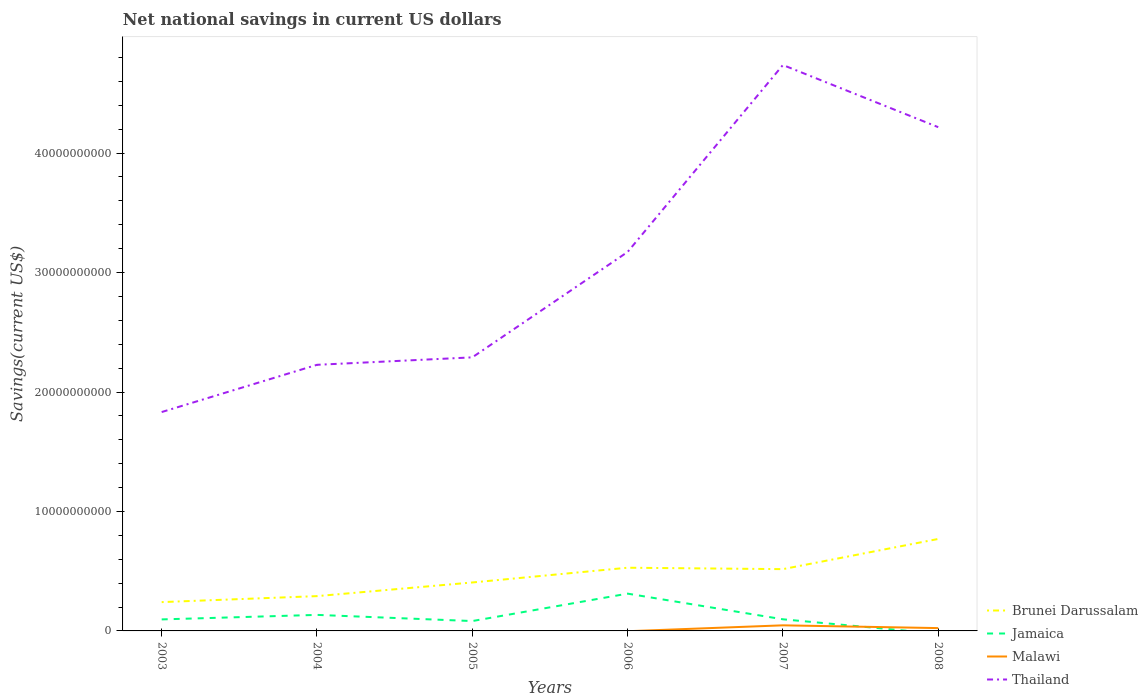Does the line corresponding to Jamaica intersect with the line corresponding to Thailand?
Your answer should be compact. No. Is the number of lines equal to the number of legend labels?
Give a very brief answer. No. What is the total net national savings in Brunei Darussalam in the graph?
Provide a succinct answer. -1.64e+09. What is the difference between the highest and the second highest net national savings in Malawi?
Your answer should be very brief. 4.68e+08. How many lines are there?
Provide a short and direct response. 4. How many years are there in the graph?
Make the answer very short. 6. Does the graph contain grids?
Your response must be concise. No. How are the legend labels stacked?
Offer a very short reply. Vertical. What is the title of the graph?
Offer a very short reply. Net national savings in current US dollars. Does "Micronesia" appear as one of the legend labels in the graph?
Provide a succinct answer. No. What is the label or title of the Y-axis?
Make the answer very short. Savings(current US$). What is the Savings(current US$) of Brunei Darussalam in 2003?
Make the answer very short. 2.41e+09. What is the Savings(current US$) of Jamaica in 2003?
Your answer should be very brief. 9.64e+08. What is the Savings(current US$) in Malawi in 2003?
Your response must be concise. 0. What is the Savings(current US$) in Thailand in 2003?
Your answer should be very brief. 1.83e+1. What is the Savings(current US$) of Brunei Darussalam in 2004?
Your response must be concise. 2.91e+09. What is the Savings(current US$) of Jamaica in 2004?
Provide a succinct answer. 1.34e+09. What is the Savings(current US$) of Malawi in 2004?
Offer a terse response. 0. What is the Savings(current US$) of Thailand in 2004?
Your answer should be very brief. 2.23e+1. What is the Savings(current US$) of Brunei Darussalam in 2005?
Offer a terse response. 4.06e+09. What is the Savings(current US$) of Jamaica in 2005?
Your answer should be compact. 8.26e+08. What is the Savings(current US$) in Thailand in 2005?
Make the answer very short. 2.29e+1. What is the Savings(current US$) in Brunei Darussalam in 2006?
Offer a very short reply. 5.29e+09. What is the Savings(current US$) in Jamaica in 2006?
Keep it short and to the point. 3.12e+09. What is the Savings(current US$) of Thailand in 2006?
Ensure brevity in your answer.  3.17e+1. What is the Savings(current US$) of Brunei Darussalam in 2007?
Provide a succinct answer. 5.17e+09. What is the Savings(current US$) in Jamaica in 2007?
Your answer should be compact. 9.73e+08. What is the Savings(current US$) of Malawi in 2007?
Your answer should be compact. 4.68e+08. What is the Savings(current US$) of Thailand in 2007?
Your response must be concise. 4.74e+1. What is the Savings(current US$) of Brunei Darussalam in 2008?
Your response must be concise. 7.70e+09. What is the Savings(current US$) in Malawi in 2008?
Give a very brief answer. 2.37e+08. What is the Savings(current US$) in Thailand in 2008?
Your response must be concise. 4.22e+1. Across all years, what is the maximum Savings(current US$) of Brunei Darussalam?
Offer a terse response. 7.70e+09. Across all years, what is the maximum Savings(current US$) of Jamaica?
Your answer should be compact. 3.12e+09. Across all years, what is the maximum Savings(current US$) of Malawi?
Offer a terse response. 4.68e+08. Across all years, what is the maximum Savings(current US$) in Thailand?
Make the answer very short. 4.74e+1. Across all years, what is the minimum Savings(current US$) of Brunei Darussalam?
Give a very brief answer. 2.41e+09. Across all years, what is the minimum Savings(current US$) of Jamaica?
Give a very brief answer. 0. Across all years, what is the minimum Savings(current US$) in Malawi?
Provide a short and direct response. 0. Across all years, what is the minimum Savings(current US$) of Thailand?
Your response must be concise. 1.83e+1. What is the total Savings(current US$) of Brunei Darussalam in the graph?
Offer a very short reply. 2.75e+1. What is the total Savings(current US$) in Jamaica in the graph?
Offer a terse response. 7.23e+09. What is the total Savings(current US$) of Malawi in the graph?
Keep it short and to the point. 7.05e+08. What is the total Savings(current US$) in Thailand in the graph?
Your response must be concise. 1.85e+11. What is the difference between the Savings(current US$) in Brunei Darussalam in 2003 and that in 2004?
Provide a succinct answer. -5.01e+08. What is the difference between the Savings(current US$) in Jamaica in 2003 and that in 2004?
Give a very brief answer. -3.78e+08. What is the difference between the Savings(current US$) of Thailand in 2003 and that in 2004?
Ensure brevity in your answer.  -3.95e+09. What is the difference between the Savings(current US$) of Brunei Darussalam in 2003 and that in 2005?
Provide a short and direct response. -1.64e+09. What is the difference between the Savings(current US$) of Jamaica in 2003 and that in 2005?
Provide a succinct answer. 1.38e+08. What is the difference between the Savings(current US$) of Thailand in 2003 and that in 2005?
Offer a very short reply. -4.58e+09. What is the difference between the Savings(current US$) in Brunei Darussalam in 2003 and that in 2006?
Provide a short and direct response. -2.88e+09. What is the difference between the Savings(current US$) in Jamaica in 2003 and that in 2006?
Your response must be concise. -2.16e+09. What is the difference between the Savings(current US$) in Thailand in 2003 and that in 2006?
Give a very brief answer. -1.34e+1. What is the difference between the Savings(current US$) of Brunei Darussalam in 2003 and that in 2007?
Offer a terse response. -2.76e+09. What is the difference between the Savings(current US$) of Jamaica in 2003 and that in 2007?
Provide a short and direct response. -9.20e+06. What is the difference between the Savings(current US$) in Thailand in 2003 and that in 2007?
Provide a short and direct response. -2.91e+1. What is the difference between the Savings(current US$) in Brunei Darussalam in 2003 and that in 2008?
Your answer should be very brief. -5.29e+09. What is the difference between the Savings(current US$) of Thailand in 2003 and that in 2008?
Offer a terse response. -2.38e+1. What is the difference between the Savings(current US$) in Brunei Darussalam in 2004 and that in 2005?
Offer a terse response. -1.14e+09. What is the difference between the Savings(current US$) of Jamaica in 2004 and that in 2005?
Give a very brief answer. 5.16e+08. What is the difference between the Savings(current US$) in Thailand in 2004 and that in 2005?
Offer a very short reply. -6.24e+08. What is the difference between the Savings(current US$) of Brunei Darussalam in 2004 and that in 2006?
Provide a short and direct response. -2.38e+09. What is the difference between the Savings(current US$) in Jamaica in 2004 and that in 2006?
Give a very brief answer. -1.78e+09. What is the difference between the Savings(current US$) of Thailand in 2004 and that in 2006?
Your response must be concise. -9.45e+09. What is the difference between the Savings(current US$) of Brunei Darussalam in 2004 and that in 2007?
Ensure brevity in your answer.  -2.26e+09. What is the difference between the Savings(current US$) in Jamaica in 2004 and that in 2007?
Make the answer very short. 3.69e+08. What is the difference between the Savings(current US$) in Thailand in 2004 and that in 2007?
Your response must be concise. -2.51e+1. What is the difference between the Savings(current US$) of Brunei Darussalam in 2004 and that in 2008?
Make the answer very short. -4.79e+09. What is the difference between the Savings(current US$) in Thailand in 2004 and that in 2008?
Give a very brief answer. -1.99e+1. What is the difference between the Savings(current US$) of Brunei Darussalam in 2005 and that in 2006?
Offer a terse response. -1.23e+09. What is the difference between the Savings(current US$) in Jamaica in 2005 and that in 2006?
Make the answer very short. -2.30e+09. What is the difference between the Savings(current US$) of Thailand in 2005 and that in 2006?
Your answer should be compact. -8.82e+09. What is the difference between the Savings(current US$) of Brunei Darussalam in 2005 and that in 2007?
Make the answer very short. -1.12e+09. What is the difference between the Savings(current US$) in Jamaica in 2005 and that in 2007?
Provide a short and direct response. -1.47e+08. What is the difference between the Savings(current US$) of Thailand in 2005 and that in 2007?
Keep it short and to the point. -2.45e+1. What is the difference between the Savings(current US$) in Brunei Darussalam in 2005 and that in 2008?
Provide a succinct answer. -3.64e+09. What is the difference between the Savings(current US$) of Thailand in 2005 and that in 2008?
Make the answer very short. -1.93e+1. What is the difference between the Savings(current US$) in Brunei Darussalam in 2006 and that in 2007?
Offer a very short reply. 1.18e+08. What is the difference between the Savings(current US$) of Jamaica in 2006 and that in 2007?
Keep it short and to the point. 2.15e+09. What is the difference between the Savings(current US$) of Thailand in 2006 and that in 2007?
Offer a very short reply. -1.57e+1. What is the difference between the Savings(current US$) of Brunei Darussalam in 2006 and that in 2008?
Your response must be concise. -2.41e+09. What is the difference between the Savings(current US$) in Thailand in 2006 and that in 2008?
Your response must be concise. -1.04e+1. What is the difference between the Savings(current US$) of Brunei Darussalam in 2007 and that in 2008?
Keep it short and to the point. -2.53e+09. What is the difference between the Savings(current US$) of Malawi in 2007 and that in 2008?
Offer a terse response. 2.31e+08. What is the difference between the Savings(current US$) in Thailand in 2007 and that in 2008?
Your answer should be very brief. 5.20e+09. What is the difference between the Savings(current US$) of Brunei Darussalam in 2003 and the Savings(current US$) of Jamaica in 2004?
Your answer should be very brief. 1.07e+09. What is the difference between the Savings(current US$) of Brunei Darussalam in 2003 and the Savings(current US$) of Thailand in 2004?
Keep it short and to the point. -1.99e+1. What is the difference between the Savings(current US$) of Jamaica in 2003 and the Savings(current US$) of Thailand in 2004?
Give a very brief answer. -2.13e+1. What is the difference between the Savings(current US$) in Brunei Darussalam in 2003 and the Savings(current US$) in Jamaica in 2005?
Provide a short and direct response. 1.59e+09. What is the difference between the Savings(current US$) in Brunei Darussalam in 2003 and the Savings(current US$) in Thailand in 2005?
Your answer should be very brief. -2.05e+1. What is the difference between the Savings(current US$) in Jamaica in 2003 and the Savings(current US$) in Thailand in 2005?
Your answer should be compact. -2.19e+1. What is the difference between the Savings(current US$) of Brunei Darussalam in 2003 and the Savings(current US$) of Jamaica in 2006?
Give a very brief answer. -7.09e+08. What is the difference between the Savings(current US$) of Brunei Darussalam in 2003 and the Savings(current US$) of Thailand in 2006?
Give a very brief answer. -2.93e+1. What is the difference between the Savings(current US$) of Jamaica in 2003 and the Savings(current US$) of Thailand in 2006?
Offer a terse response. -3.08e+1. What is the difference between the Savings(current US$) in Brunei Darussalam in 2003 and the Savings(current US$) in Jamaica in 2007?
Your answer should be very brief. 1.44e+09. What is the difference between the Savings(current US$) of Brunei Darussalam in 2003 and the Savings(current US$) of Malawi in 2007?
Provide a succinct answer. 1.94e+09. What is the difference between the Savings(current US$) of Brunei Darussalam in 2003 and the Savings(current US$) of Thailand in 2007?
Your response must be concise. -4.50e+1. What is the difference between the Savings(current US$) in Jamaica in 2003 and the Savings(current US$) in Malawi in 2007?
Your answer should be compact. 4.96e+08. What is the difference between the Savings(current US$) of Jamaica in 2003 and the Savings(current US$) of Thailand in 2007?
Give a very brief answer. -4.64e+1. What is the difference between the Savings(current US$) of Brunei Darussalam in 2003 and the Savings(current US$) of Malawi in 2008?
Offer a very short reply. 2.18e+09. What is the difference between the Savings(current US$) in Brunei Darussalam in 2003 and the Savings(current US$) in Thailand in 2008?
Provide a succinct answer. -3.98e+1. What is the difference between the Savings(current US$) of Jamaica in 2003 and the Savings(current US$) of Malawi in 2008?
Your response must be concise. 7.27e+08. What is the difference between the Savings(current US$) in Jamaica in 2003 and the Savings(current US$) in Thailand in 2008?
Your response must be concise. -4.12e+1. What is the difference between the Savings(current US$) of Brunei Darussalam in 2004 and the Savings(current US$) of Jamaica in 2005?
Provide a succinct answer. 2.09e+09. What is the difference between the Savings(current US$) of Brunei Darussalam in 2004 and the Savings(current US$) of Thailand in 2005?
Offer a terse response. -2.00e+1. What is the difference between the Savings(current US$) of Jamaica in 2004 and the Savings(current US$) of Thailand in 2005?
Offer a terse response. -2.16e+1. What is the difference between the Savings(current US$) of Brunei Darussalam in 2004 and the Savings(current US$) of Jamaica in 2006?
Ensure brevity in your answer.  -2.08e+08. What is the difference between the Savings(current US$) in Brunei Darussalam in 2004 and the Savings(current US$) in Thailand in 2006?
Give a very brief answer. -2.88e+1. What is the difference between the Savings(current US$) in Jamaica in 2004 and the Savings(current US$) in Thailand in 2006?
Ensure brevity in your answer.  -3.04e+1. What is the difference between the Savings(current US$) of Brunei Darussalam in 2004 and the Savings(current US$) of Jamaica in 2007?
Give a very brief answer. 1.94e+09. What is the difference between the Savings(current US$) in Brunei Darussalam in 2004 and the Savings(current US$) in Malawi in 2007?
Your answer should be compact. 2.45e+09. What is the difference between the Savings(current US$) in Brunei Darussalam in 2004 and the Savings(current US$) in Thailand in 2007?
Give a very brief answer. -4.45e+1. What is the difference between the Savings(current US$) in Jamaica in 2004 and the Savings(current US$) in Malawi in 2007?
Your answer should be very brief. 8.74e+08. What is the difference between the Savings(current US$) in Jamaica in 2004 and the Savings(current US$) in Thailand in 2007?
Provide a succinct answer. -4.60e+1. What is the difference between the Savings(current US$) in Brunei Darussalam in 2004 and the Savings(current US$) in Malawi in 2008?
Keep it short and to the point. 2.68e+09. What is the difference between the Savings(current US$) in Brunei Darussalam in 2004 and the Savings(current US$) in Thailand in 2008?
Your answer should be compact. -3.93e+1. What is the difference between the Savings(current US$) of Jamaica in 2004 and the Savings(current US$) of Malawi in 2008?
Provide a short and direct response. 1.11e+09. What is the difference between the Savings(current US$) of Jamaica in 2004 and the Savings(current US$) of Thailand in 2008?
Provide a short and direct response. -4.08e+1. What is the difference between the Savings(current US$) of Brunei Darussalam in 2005 and the Savings(current US$) of Jamaica in 2006?
Keep it short and to the point. 9.35e+08. What is the difference between the Savings(current US$) of Brunei Darussalam in 2005 and the Savings(current US$) of Thailand in 2006?
Ensure brevity in your answer.  -2.77e+1. What is the difference between the Savings(current US$) in Jamaica in 2005 and the Savings(current US$) in Thailand in 2006?
Your answer should be compact. -3.09e+1. What is the difference between the Savings(current US$) in Brunei Darussalam in 2005 and the Savings(current US$) in Jamaica in 2007?
Provide a succinct answer. 3.08e+09. What is the difference between the Savings(current US$) in Brunei Darussalam in 2005 and the Savings(current US$) in Malawi in 2007?
Ensure brevity in your answer.  3.59e+09. What is the difference between the Savings(current US$) of Brunei Darussalam in 2005 and the Savings(current US$) of Thailand in 2007?
Your answer should be compact. -4.33e+1. What is the difference between the Savings(current US$) of Jamaica in 2005 and the Savings(current US$) of Malawi in 2007?
Ensure brevity in your answer.  3.58e+08. What is the difference between the Savings(current US$) of Jamaica in 2005 and the Savings(current US$) of Thailand in 2007?
Provide a succinct answer. -4.65e+1. What is the difference between the Savings(current US$) in Brunei Darussalam in 2005 and the Savings(current US$) in Malawi in 2008?
Offer a very short reply. 3.82e+09. What is the difference between the Savings(current US$) of Brunei Darussalam in 2005 and the Savings(current US$) of Thailand in 2008?
Offer a very short reply. -3.81e+1. What is the difference between the Savings(current US$) of Jamaica in 2005 and the Savings(current US$) of Malawi in 2008?
Provide a succinct answer. 5.89e+08. What is the difference between the Savings(current US$) of Jamaica in 2005 and the Savings(current US$) of Thailand in 2008?
Keep it short and to the point. -4.13e+1. What is the difference between the Savings(current US$) in Brunei Darussalam in 2006 and the Savings(current US$) in Jamaica in 2007?
Ensure brevity in your answer.  4.32e+09. What is the difference between the Savings(current US$) in Brunei Darussalam in 2006 and the Savings(current US$) in Malawi in 2007?
Ensure brevity in your answer.  4.82e+09. What is the difference between the Savings(current US$) in Brunei Darussalam in 2006 and the Savings(current US$) in Thailand in 2007?
Provide a short and direct response. -4.21e+1. What is the difference between the Savings(current US$) in Jamaica in 2006 and the Savings(current US$) in Malawi in 2007?
Keep it short and to the point. 2.65e+09. What is the difference between the Savings(current US$) of Jamaica in 2006 and the Savings(current US$) of Thailand in 2007?
Your answer should be compact. -4.43e+1. What is the difference between the Savings(current US$) of Brunei Darussalam in 2006 and the Savings(current US$) of Malawi in 2008?
Your answer should be compact. 5.05e+09. What is the difference between the Savings(current US$) in Brunei Darussalam in 2006 and the Savings(current US$) in Thailand in 2008?
Keep it short and to the point. -3.69e+1. What is the difference between the Savings(current US$) in Jamaica in 2006 and the Savings(current US$) in Malawi in 2008?
Offer a very short reply. 2.88e+09. What is the difference between the Savings(current US$) of Jamaica in 2006 and the Savings(current US$) of Thailand in 2008?
Keep it short and to the point. -3.91e+1. What is the difference between the Savings(current US$) of Brunei Darussalam in 2007 and the Savings(current US$) of Malawi in 2008?
Give a very brief answer. 4.94e+09. What is the difference between the Savings(current US$) in Brunei Darussalam in 2007 and the Savings(current US$) in Thailand in 2008?
Give a very brief answer. -3.70e+1. What is the difference between the Savings(current US$) of Jamaica in 2007 and the Savings(current US$) of Malawi in 2008?
Provide a short and direct response. 7.37e+08. What is the difference between the Savings(current US$) in Jamaica in 2007 and the Savings(current US$) in Thailand in 2008?
Offer a terse response. -4.12e+1. What is the difference between the Savings(current US$) in Malawi in 2007 and the Savings(current US$) in Thailand in 2008?
Give a very brief answer. -4.17e+1. What is the average Savings(current US$) in Brunei Darussalam per year?
Give a very brief answer. 4.59e+09. What is the average Savings(current US$) of Jamaica per year?
Offer a terse response. 1.20e+09. What is the average Savings(current US$) in Malawi per year?
Your answer should be compact. 1.17e+08. What is the average Savings(current US$) of Thailand per year?
Provide a short and direct response. 3.08e+1. In the year 2003, what is the difference between the Savings(current US$) in Brunei Darussalam and Savings(current US$) in Jamaica?
Your response must be concise. 1.45e+09. In the year 2003, what is the difference between the Savings(current US$) in Brunei Darussalam and Savings(current US$) in Thailand?
Your answer should be very brief. -1.59e+1. In the year 2003, what is the difference between the Savings(current US$) of Jamaica and Savings(current US$) of Thailand?
Your answer should be very brief. -1.74e+1. In the year 2004, what is the difference between the Savings(current US$) of Brunei Darussalam and Savings(current US$) of Jamaica?
Provide a short and direct response. 1.57e+09. In the year 2004, what is the difference between the Savings(current US$) of Brunei Darussalam and Savings(current US$) of Thailand?
Your response must be concise. -1.94e+1. In the year 2004, what is the difference between the Savings(current US$) of Jamaica and Savings(current US$) of Thailand?
Provide a succinct answer. -2.09e+1. In the year 2005, what is the difference between the Savings(current US$) of Brunei Darussalam and Savings(current US$) of Jamaica?
Provide a succinct answer. 3.23e+09. In the year 2005, what is the difference between the Savings(current US$) in Brunei Darussalam and Savings(current US$) in Thailand?
Your response must be concise. -1.88e+1. In the year 2005, what is the difference between the Savings(current US$) in Jamaica and Savings(current US$) in Thailand?
Ensure brevity in your answer.  -2.21e+1. In the year 2006, what is the difference between the Savings(current US$) of Brunei Darussalam and Savings(current US$) of Jamaica?
Offer a very short reply. 2.17e+09. In the year 2006, what is the difference between the Savings(current US$) of Brunei Darussalam and Savings(current US$) of Thailand?
Provide a succinct answer. -2.64e+1. In the year 2006, what is the difference between the Savings(current US$) of Jamaica and Savings(current US$) of Thailand?
Provide a succinct answer. -2.86e+1. In the year 2007, what is the difference between the Savings(current US$) of Brunei Darussalam and Savings(current US$) of Jamaica?
Your answer should be compact. 4.20e+09. In the year 2007, what is the difference between the Savings(current US$) in Brunei Darussalam and Savings(current US$) in Malawi?
Provide a short and direct response. 4.70e+09. In the year 2007, what is the difference between the Savings(current US$) in Brunei Darussalam and Savings(current US$) in Thailand?
Give a very brief answer. -4.22e+1. In the year 2007, what is the difference between the Savings(current US$) of Jamaica and Savings(current US$) of Malawi?
Make the answer very short. 5.05e+08. In the year 2007, what is the difference between the Savings(current US$) in Jamaica and Savings(current US$) in Thailand?
Keep it short and to the point. -4.64e+1. In the year 2007, what is the difference between the Savings(current US$) of Malawi and Savings(current US$) of Thailand?
Your answer should be very brief. -4.69e+1. In the year 2008, what is the difference between the Savings(current US$) in Brunei Darussalam and Savings(current US$) in Malawi?
Offer a very short reply. 7.46e+09. In the year 2008, what is the difference between the Savings(current US$) of Brunei Darussalam and Savings(current US$) of Thailand?
Your answer should be compact. -3.45e+1. In the year 2008, what is the difference between the Savings(current US$) of Malawi and Savings(current US$) of Thailand?
Keep it short and to the point. -4.19e+1. What is the ratio of the Savings(current US$) of Brunei Darussalam in 2003 to that in 2004?
Provide a succinct answer. 0.83. What is the ratio of the Savings(current US$) in Jamaica in 2003 to that in 2004?
Your answer should be very brief. 0.72. What is the ratio of the Savings(current US$) in Thailand in 2003 to that in 2004?
Your answer should be compact. 0.82. What is the ratio of the Savings(current US$) in Brunei Darussalam in 2003 to that in 2005?
Your answer should be compact. 0.59. What is the ratio of the Savings(current US$) of Jamaica in 2003 to that in 2005?
Make the answer very short. 1.17. What is the ratio of the Savings(current US$) of Thailand in 2003 to that in 2005?
Give a very brief answer. 0.8. What is the ratio of the Savings(current US$) in Brunei Darussalam in 2003 to that in 2006?
Your answer should be compact. 0.46. What is the ratio of the Savings(current US$) of Jamaica in 2003 to that in 2006?
Make the answer very short. 0.31. What is the ratio of the Savings(current US$) of Thailand in 2003 to that in 2006?
Your response must be concise. 0.58. What is the ratio of the Savings(current US$) in Brunei Darussalam in 2003 to that in 2007?
Keep it short and to the point. 0.47. What is the ratio of the Savings(current US$) of Thailand in 2003 to that in 2007?
Give a very brief answer. 0.39. What is the ratio of the Savings(current US$) in Brunei Darussalam in 2003 to that in 2008?
Make the answer very short. 0.31. What is the ratio of the Savings(current US$) in Thailand in 2003 to that in 2008?
Make the answer very short. 0.43. What is the ratio of the Savings(current US$) of Brunei Darussalam in 2004 to that in 2005?
Keep it short and to the point. 0.72. What is the ratio of the Savings(current US$) of Jamaica in 2004 to that in 2005?
Offer a terse response. 1.63. What is the ratio of the Savings(current US$) of Thailand in 2004 to that in 2005?
Make the answer very short. 0.97. What is the ratio of the Savings(current US$) in Brunei Darussalam in 2004 to that in 2006?
Make the answer very short. 0.55. What is the ratio of the Savings(current US$) of Jamaica in 2004 to that in 2006?
Ensure brevity in your answer.  0.43. What is the ratio of the Savings(current US$) in Thailand in 2004 to that in 2006?
Your answer should be compact. 0.7. What is the ratio of the Savings(current US$) in Brunei Darussalam in 2004 to that in 2007?
Your answer should be compact. 0.56. What is the ratio of the Savings(current US$) in Jamaica in 2004 to that in 2007?
Keep it short and to the point. 1.38. What is the ratio of the Savings(current US$) of Thailand in 2004 to that in 2007?
Keep it short and to the point. 0.47. What is the ratio of the Savings(current US$) of Brunei Darussalam in 2004 to that in 2008?
Your answer should be very brief. 0.38. What is the ratio of the Savings(current US$) of Thailand in 2004 to that in 2008?
Your answer should be very brief. 0.53. What is the ratio of the Savings(current US$) of Brunei Darussalam in 2005 to that in 2006?
Your response must be concise. 0.77. What is the ratio of the Savings(current US$) in Jamaica in 2005 to that in 2006?
Ensure brevity in your answer.  0.26. What is the ratio of the Savings(current US$) of Thailand in 2005 to that in 2006?
Offer a very short reply. 0.72. What is the ratio of the Savings(current US$) in Brunei Darussalam in 2005 to that in 2007?
Provide a succinct answer. 0.78. What is the ratio of the Savings(current US$) in Jamaica in 2005 to that in 2007?
Provide a succinct answer. 0.85. What is the ratio of the Savings(current US$) in Thailand in 2005 to that in 2007?
Keep it short and to the point. 0.48. What is the ratio of the Savings(current US$) in Brunei Darussalam in 2005 to that in 2008?
Give a very brief answer. 0.53. What is the ratio of the Savings(current US$) of Thailand in 2005 to that in 2008?
Your answer should be very brief. 0.54. What is the ratio of the Savings(current US$) in Brunei Darussalam in 2006 to that in 2007?
Your answer should be compact. 1.02. What is the ratio of the Savings(current US$) in Jamaica in 2006 to that in 2007?
Your response must be concise. 3.21. What is the ratio of the Savings(current US$) in Thailand in 2006 to that in 2007?
Offer a very short reply. 0.67. What is the ratio of the Savings(current US$) of Brunei Darussalam in 2006 to that in 2008?
Ensure brevity in your answer.  0.69. What is the ratio of the Savings(current US$) in Thailand in 2006 to that in 2008?
Ensure brevity in your answer.  0.75. What is the ratio of the Savings(current US$) of Brunei Darussalam in 2007 to that in 2008?
Provide a succinct answer. 0.67. What is the ratio of the Savings(current US$) in Malawi in 2007 to that in 2008?
Provide a succinct answer. 1.98. What is the ratio of the Savings(current US$) of Thailand in 2007 to that in 2008?
Offer a very short reply. 1.12. What is the difference between the highest and the second highest Savings(current US$) in Brunei Darussalam?
Ensure brevity in your answer.  2.41e+09. What is the difference between the highest and the second highest Savings(current US$) of Jamaica?
Keep it short and to the point. 1.78e+09. What is the difference between the highest and the second highest Savings(current US$) of Thailand?
Your answer should be very brief. 5.20e+09. What is the difference between the highest and the lowest Savings(current US$) of Brunei Darussalam?
Provide a succinct answer. 5.29e+09. What is the difference between the highest and the lowest Savings(current US$) in Jamaica?
Provide a short and direct response. 3.12e+09. What is the difference between the highest and the lowest Savings(current US$) of Malawi?
Give a very brief answer. 4.68e+08. What is the difference between the highest and the lowest Savings(current US$) in Thailand?
Ensure brevity in your answer.  2.91e+1. 